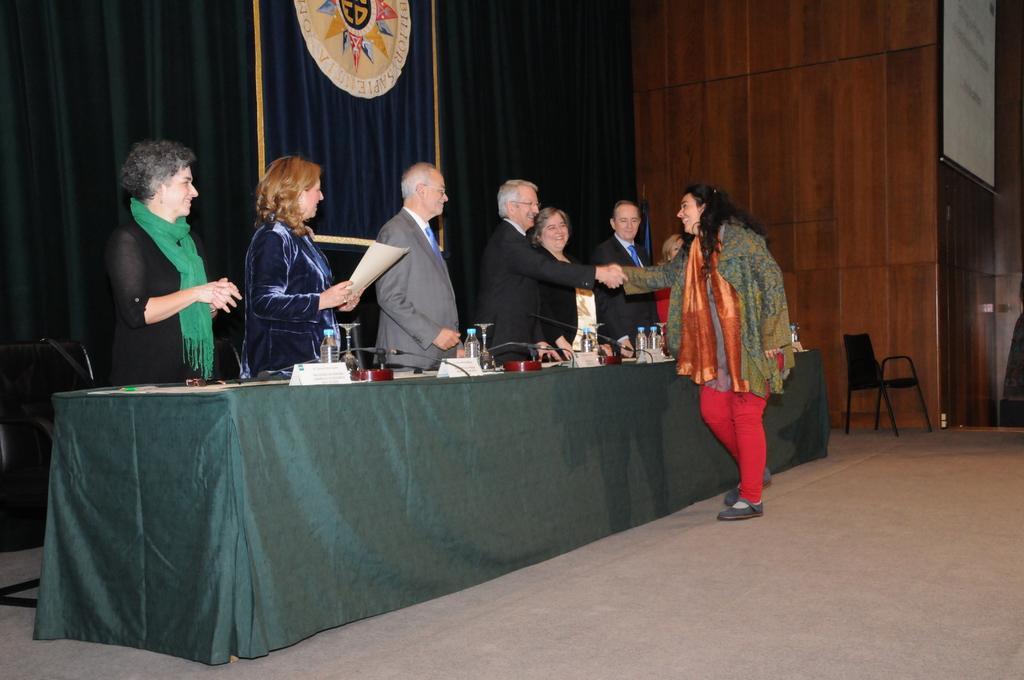Can you describe this image briefly? In this picture there some old men wearing black color suit, and standing in front. Beside there is a woman shaking the hand with the old man. In the center there is a table with water bottles and microphone. In the background there is a black curtain and wooden panel wall. 